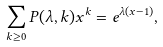Convert formula to latex. <formula><loc_0><loc_0><loc_500><loc_500>\sum _ { k \geq 0 } P ( \lambda , k ) x ^ { k } = e ^ { \lambda ( x - 1 ) } ,</formula> 